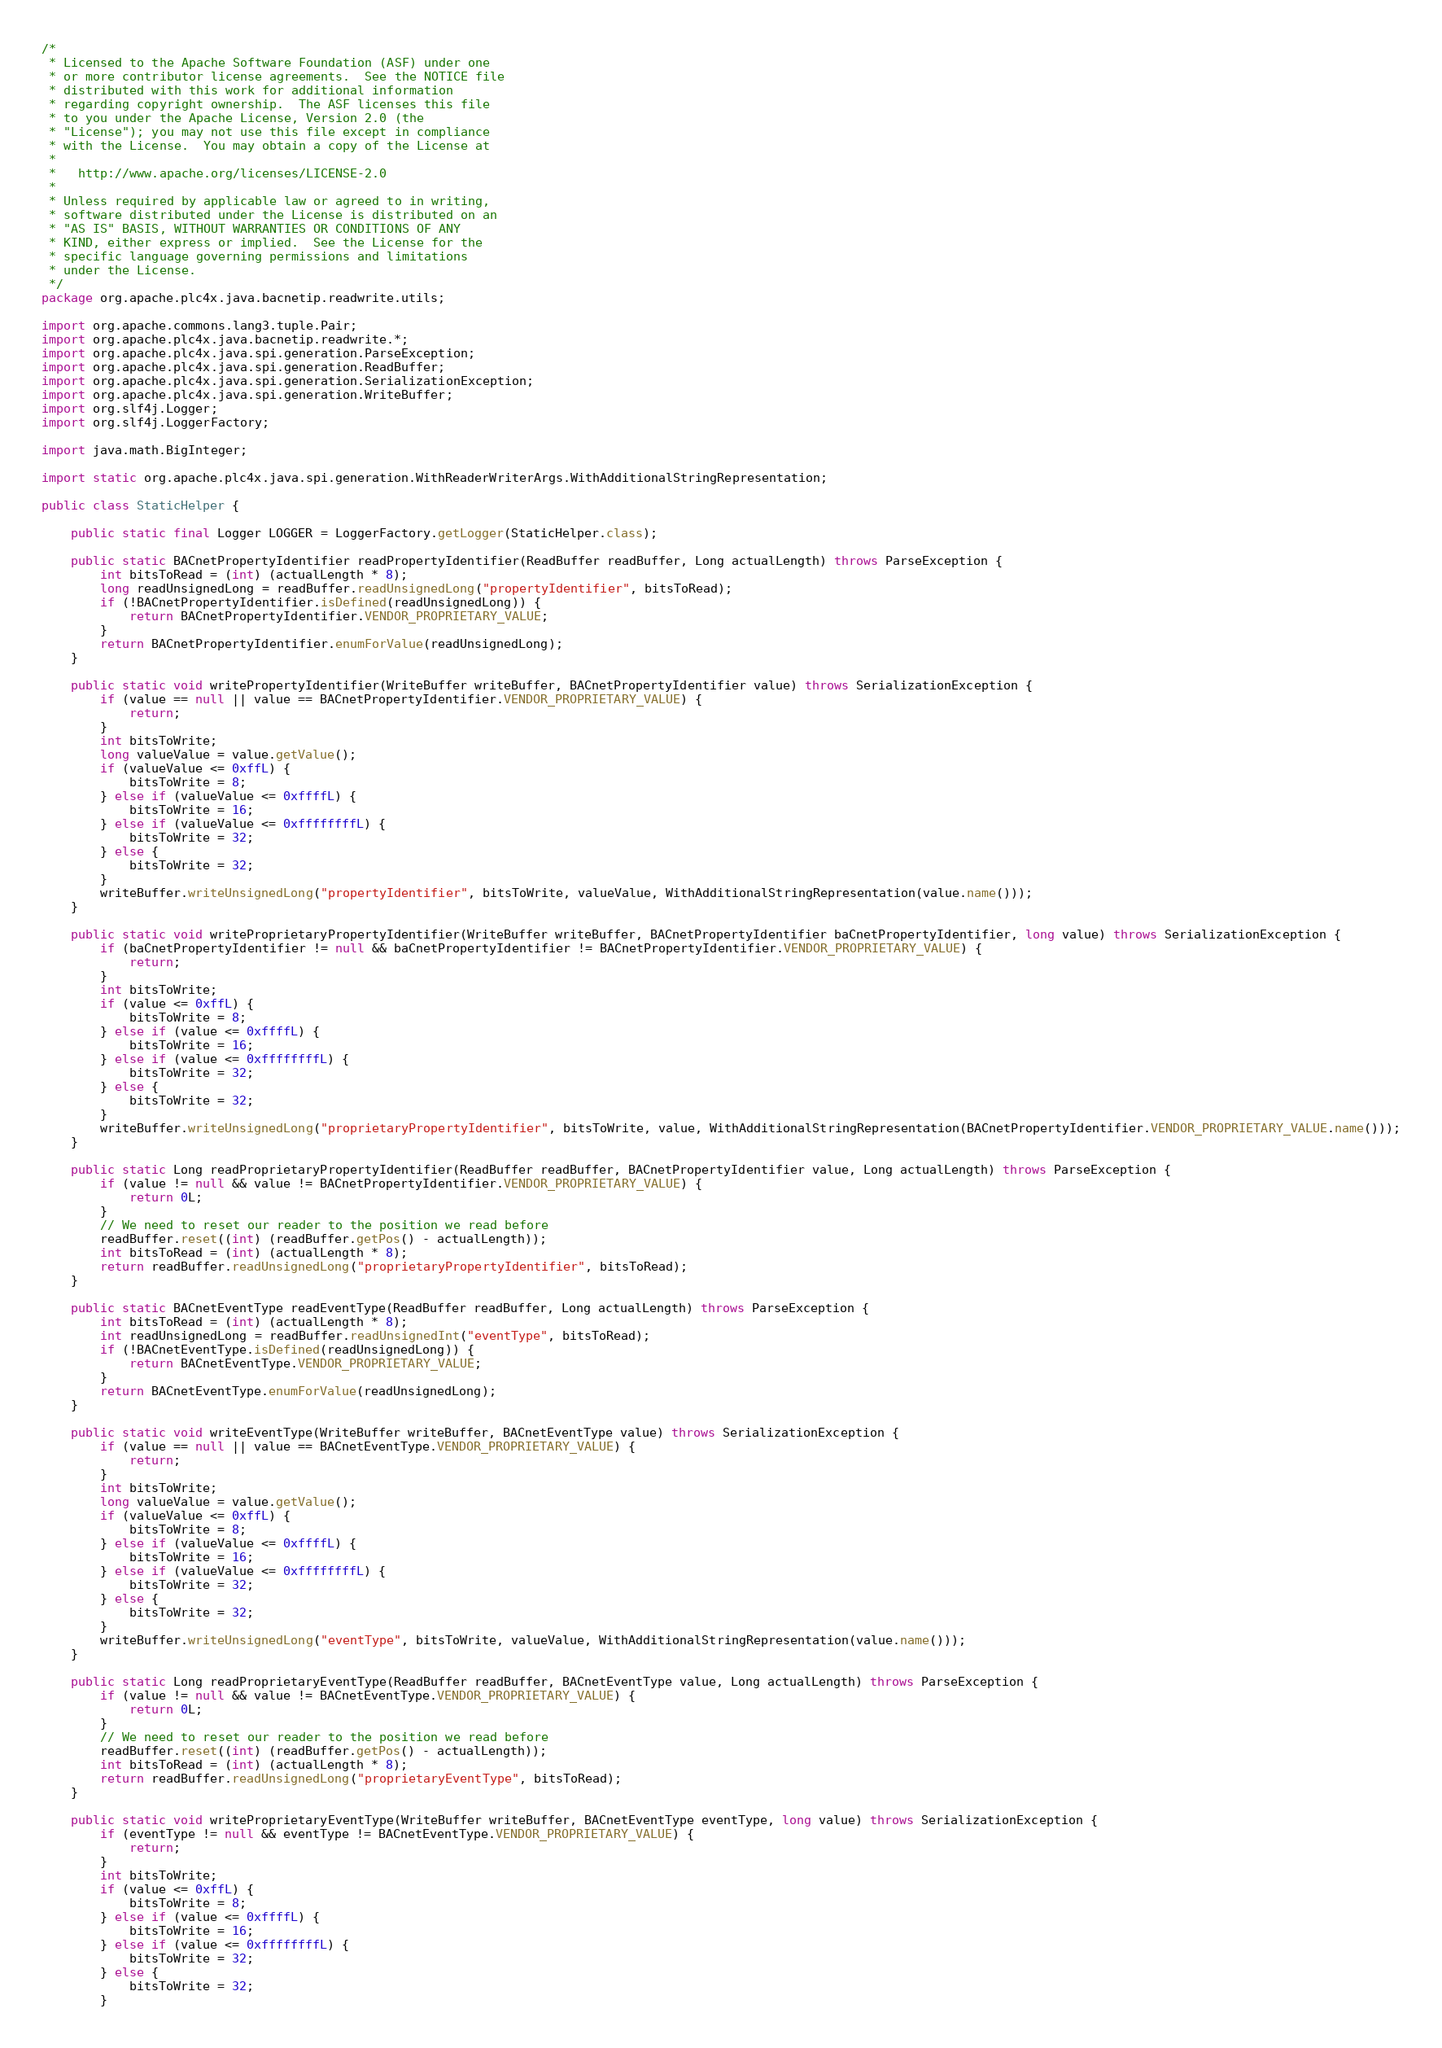<code> <loc_0><loc_0><loc_500><loc_500><_Java_>/*
 * Licensed to the Apache Software Foundation (ASF) under one
 * or more contributor license agreements.  See the NOTICE file
 * distributed with this work for additional information
 * regarding copyright ownership.  The ASF licenses this file
 * to you under the Apache License, Version 2.0 (the
 * "License"); you may not use this file except in compliance
 * with the License.  You may obtain a copy of the License at
 *
 *   http://www.apache.org/licenses/LICENSE-2.0
 *
 * Unless required by applicable law or agreed to in writing,
 * software distributed under the License is distributed on an
 * "AS IS" BASIS, WITHOUT WARRANTIES OR CONDITIONS OF ANY
 * KIND, either express or implied.  See the License for the
 * specific language governing permissions and limitations
 * under the License.
 */
package org.apache.plc4x.java.bacnetip.readwrite.utils;

import org.apache.commons.lang3.tuple.Pair;
import org.apache.plc4x.java.bacnetip.readwrite.*;
import org.apache.plc4x.java.spi.generation.ParseException;
import org.apache.plc4x.java.spi.generation.ReadBuffer;
import org.apache.plc4x.java.spi.generation.SerializationException;
import org.apache.plc4x.java.spi.generation.WriteBuffer;
import org.slf4j.Logger;
import org.slf4j.LoggerFactory;

import java.math.BigInteger;

import static org.apache.plc4x.java.spi.generation.WithReaderWriterArgs.WithAdditionalStringRepresentation;

public class StaticHelper {

    public static final Logger LOGGER = LoggerFactory.getLogger(StaticHelper.class);

    public static BACnetPropertyIdentifier readPropertyIdentifier(ReadBuffer readBuffer, Long actualLength) throws ParseException {
        int bitsToRead = (int) (actualLength * 8);
        long readUnsignedLong = readBuffer.readUnsignedLong("propertyIdentifier", bitsToRead);
        if (!BACnetPropertyIdentifier.isDefined(readUnsignedLong)) {
            return BACnetPropertyIdentifier.VENDOR_PROPRIETARY_VALUE;
        }
        return BACnetPropertyIdentifier.enumForValue(readUnsignedLong);
    }

    public static void writePropertyIdentifier(WriteBuffer writeBuffer, BACnetPropertyIdentifier value) throws SerializationException {
        if (value == null || value == BACnetPropertyIdentifier.VENDOR_PROPRIETARY_VALUE) {
            return;
        }
        int bitsToWrite;
        long valueValue = value.getValue();
        if (valueValue <= 0xffL) {
            bitsToWrite = 8;
        } else if (valueValue <= 0xffffL) {
            bitsToWrite = 16;
        } else if (valueValue <= 0xffffffffL) {
            bitsToWrite = 32;
        } else {
            bitsToWrite = 32;
        }
        writeBuffer.writeUnsignedLong("propertyIdentifier", bitsToWrite, valueValue, WithAdditionalStringRepresentation(value.name()));
    }

    public static void writeProprietaryPropertyIdentifier(WriteBuffer writeBuffer, BACnetPropertyIdentifier baCnetPropertyIdentifier, long value) throws SerializationException {
        if (baCnetPropertyIdentifier != null && baCnetPropertyIdentifier != BACnetPropertyIdentifier.VENDOR_PROPRIETARY_VALUE) {
            return;
        }
        int bitsToWrite;
        if (value <= 0xffL) {
            bitsToWrite = 8;
        } else if (value <= 0xffffL) {
            bitsToWrite = 16;
        } else if (value <= 0xffffffffL) {
            bitsToWrite = 32;
        } else {
            bitsToWrite = 32;
        }
        writeBuffer.writeUnsignedLong("proprietaryPropertyIdentifier", bitsToWrite, value, WithAdditionalStringRepresentation(BACnetPropertyIdentifier.VENDOR_PROPRIETARY_VALUE.name()));
    }

    public static Long readProprietaryPropertyIdentifier(ReadBuffer readBuffer, BACnetPropertyIdentifier value, Long actualLength) throws ParseException {
        if (value != null && value != BACnetPropertyIdentifier.VENDOR_PROPRIETARY_VALUE) {
            return 0L;
        }
        // We need to reset our reader to the position we read before
        readBuffer.reset((int) (readBuffer.getPos() - actualLength));
        int bitsToRead = (int) (actualLength * 8);
        return readBuffer.readUnsignedLong("proprietaryPropertyIdentifier", bitsToRead);
    }

    public static BACnetEventType readEventType(ReadBuffer readBuffer, Long actualLength) throws ParseException {
        int bitsToRead = (int) (actualLength * 8);
        int readUnsignedLong = readBuffer.readUnsignedInt("eventType", bitsToRead);
        if (!BACnetEventType.isDefined(readUnsignedLong)) {
            return BACnetEventType.VENDOR_PROPRIETARY_VALUE;
        }
        return BACnetEventType.enumForValue(readUnsignedLong);
    }

    public static void writeEventType(WriteBuffer writeBuffer, BACnetEventType value) throws SerializationException {
        if (value == null || value == BACnetEventType.VENDOR_PROPRIETARY_VALUE) {
            return;
        }
        int bitsToWrite;
        long valueValue = value.getValue();
        if (valueValue <= 0xffL) {
            bitsToWrite = 8;
        } else if (valueValue <= 0xffffL) {
            bitsToWrite = 16;
        } else if (valueValue <= 0xffffffffL) {
            bitsToWrite = 32;
        } else {
            bitsToWrite = 32;
        }
        writeBuffer.writeUnsignedLong("eventType", bitsToWrite, valueValue, WithAdditionalStringRepresentation(value.name()));
    }

    public static Long readProprietaryEventType(ReadBuffer readBuffer, BACnetEventType value, Long actualLength) throws ParseException {
        if (value != null && value != BACnetEventType.VENDOR_PROPRIETARY_VALUE) {
            return 0L;
        }
        // We need to reset our reader to the position we read before
        readBuffer.reset((int) (readBuffer.getPos() - actualLength));
        int bitsToRead = (int) (actualLength * 8);
        return readBuffer.readUnsignedLong("proprietaryEventType", bitsToRead);
    }

    public static void writeProprietaryEventType(WriteBuffer writeBuffer, BACnetEventType eventType, long value) throws SerializationException {
        if (eventType != null && eventType != BACnetEventType.VENDOR_PROPRIETARY_VALUE) {
            return;
        }
        int bitsToWrite;
        if (value <= 0xffL) {
            bitsToWrite = 8;
        } else if (value <= 0xffffL) {
            bitsToWrite = 16;
        } else if (value <= 0xffffffffL) {
            bitsToWrite = 32;
        } else {
            bitsToWrite = 32;
        }</code> 